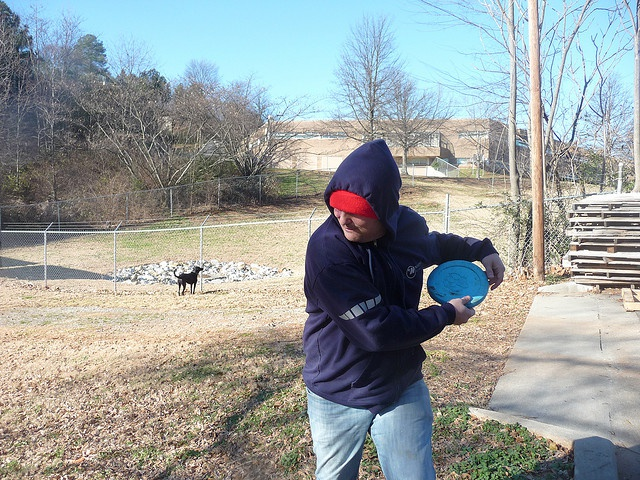Describe the objects in this image and their specific colors. I can see people in gray, black, and navy tones, frisbee in gray, teal, blue, and navy tones, and dog in gray, black, darkgray, and ivory tones in this image. 